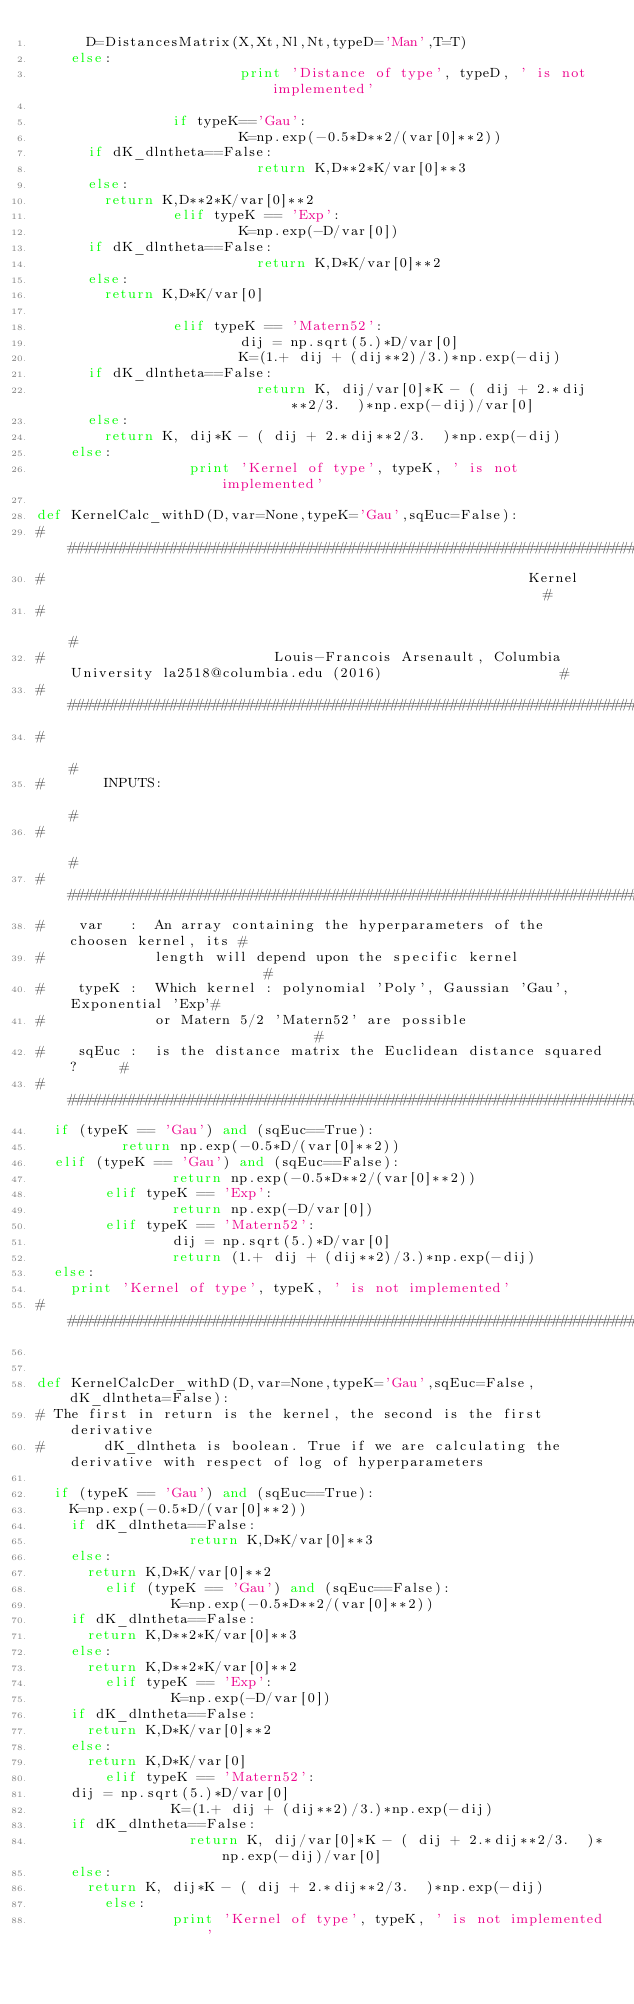Convert code to text. <code><loc_0><loc_0><loc_500><loc_500><_Python_>			D=DistancesMatrix(X,Xt,Nl,Nt,typeD='Man',T=T)
		else:
                        print 'Distance of type', typeD, ' is not implemented'

                if typeK=='Gau':
                        K=np.exp(-0.5*D**2/(var[0]**2))
			if dK_dlntheta==False:
                        	return K,D**2*K/var[0]**3
			else:
				return K,D**2*K/var[0]**2
                elif typeK == 'Exp': 
                        K=np.exp(-D/var[0])
			if dK_dlntheta==False:	
                        	return K,D*K/var[0]**2
			else:
				return K,D*K/var[0]

                elif typeK == 'Matern52':
                        dij = np.sqrt(5.)*D/var[0]
                        K=(1.+ dij + (dij**2)/3.)*np.exp(-dij)
			if dK_dlntheta==False:
                        	return K, dij/var[0]*K - ( dij + 2.*dij**2/3.  )*np.exp(-dij)/var[0]
			else:
				return K, dij*K - ( dij + 2.*dij**2/3.  )*np.exp(-dij)
		else:
                	print 'Kernel of type', typeK, ' is not implemented'

def KernelCalc_withD(D,var=None,typeK='Gau',sqEuc=False):
##########################################################################################################################
#                                                         Kernel                                                         #
#                                                                                                                        #
#                           Louis-Francois Arsenault, Columbia University la2518@columbia.edu (2016)                     #
##########################################################################################################################
#                                                                                                                        #
#       INPUTS:                                                                                                          #
#                                                                                                                        #
##################################################################################
#    var   :  An array containing the hyperparameters of the choosen kernel, its #
#             length will depend upon the specific kernel                        #
#    typeK :  Which kernel : polynomial 'Poly', Gaussian 'Gau', Exponential 'Exp'# 
#             or Matern 5/2 'Matern52' are possible                              #
#    sqEuc :  is the distance matrix the Euclidean distance squared?		 #
##################################################################################
	if (typeK == 'Gau') and (sqEuc==True):
        	return np.exp(-0.5*D/(var[0]**2))
	elif (typeK == 'Gau') and (sqEuc==False):
                return np.exp(-0.5*D**2/(var[0]**2))
        elif typeK == 'Exp':
                return np.exp(-D/var[0])
        elif typeK == 'Matern52':
                dij = np.sqrt(5.)*D/var[0]
                return (1.+ dij + (dij**2)/3.)*np.exp(-dij)
	else:
		print 'Kernel of type', typeK, ' is not implemented'
#########################################################################################################################


def KernelCalcDer_withD(D,var=None,typeK='Gau',sqEuc=False,dK_dlntheta=False):
#	The first in return is the kernel, the second is the first derivative
#       dK_dlntheta is boolean. True if we are calculating the derivative with respect of log of hyperparameters

	if (typeK == 'Gau') and (sqEuc==True):
		K=np.exp(-0.5*D/(var[0]**2))
		if dK_dlntheta==False:
                	return K,D*K/var[0]**3
		else:
			return K,D*K/var[0]**2
        elif (typeK == 'Gau') and (sqEuc==False):
                K=np.exp(-0.5*D**2/(var[0]**2))
		if dK_dlntheta==False:
			return K,D**2*K/var[0]**3
		else:
			return K,D**2*K/var[0]**2
        elif typeK == 'Exp':
                K=np.exp(-D/var[0])
		if dK_dlntheta==False:
			return K,D*K/var[0]**2
		else:
			return K,D*K/var[0]
        elif typeK == 'Matern52':
		dij = np.sqrt(5.)*D/var[0]
                K=(1.+ dij + (dij**2)/3.)*np.exp(-dij)
		if dK_dlntheta==False:
                	return K, dij/var[0]*K - ( dij + 2.*dij**2/3.  )*np.exp(-dij)/var[0]
		else:
			return K, dij*K - ( dij + 2.*dij**2/3.  )*np.exp(-dij)
        else:
                print 'Kernel of type', typeK, ' is not implemented'

</code> 